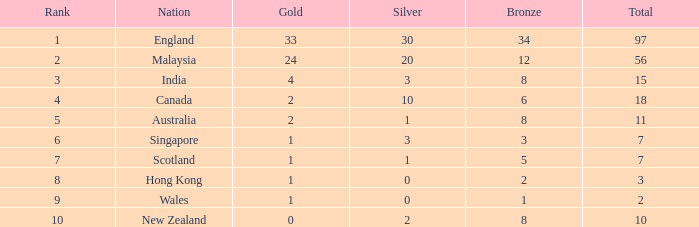Considering scotland's total medal count is less than 7, what is their bronze medal count? None. 